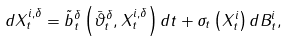Convert formula to latex. <formula><loc_0><loc_0><loc_500><loc_500>d X _ { t } ^ { i , \delta } = \tilde { b } _ { t } ^ { \delta } \left ( \bar { \vartheta } _ { t } ^ { \delta } , X _ { t } ^ { i , \delta } \right ) d t + \sigma _ { t } \left ( X _ { t } ^ { i } \right ) d B _ { t } ^ { i } ,</formula> 